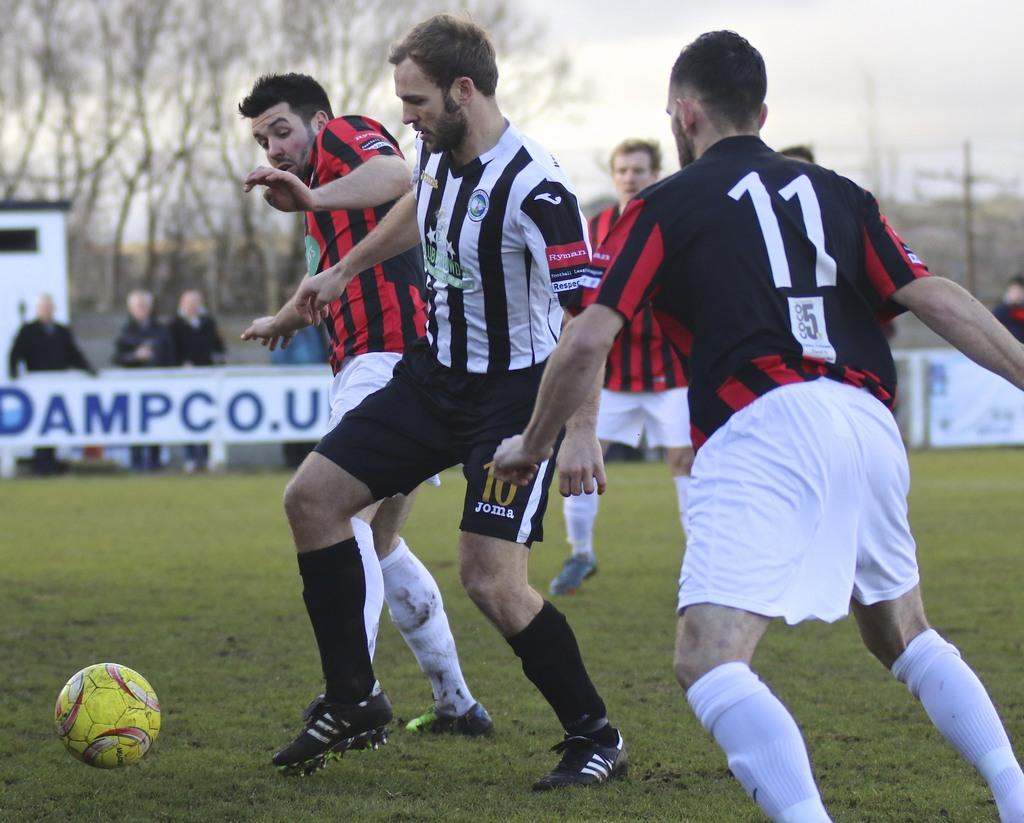Provide a one-sentence caption for the provided image. Soccer players on the field in front of a banner with Dampco.u on it in blue. 